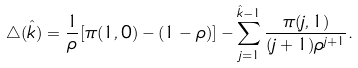<formula> <loc_0><loc_0><loc_500><loc_500>\triangle ( \hat { k } ) = \frac { 1 } { \rho } [ \pi ( 1 , 0 ) - ( 1 - \rho ) ] - \sum _ { j = 1 } ^ { \hat { k } - 1 } \frac { \pi ( j , 1 ) } { ( j + 1 ) \rho ^ { j + 1 } } .</formula> 